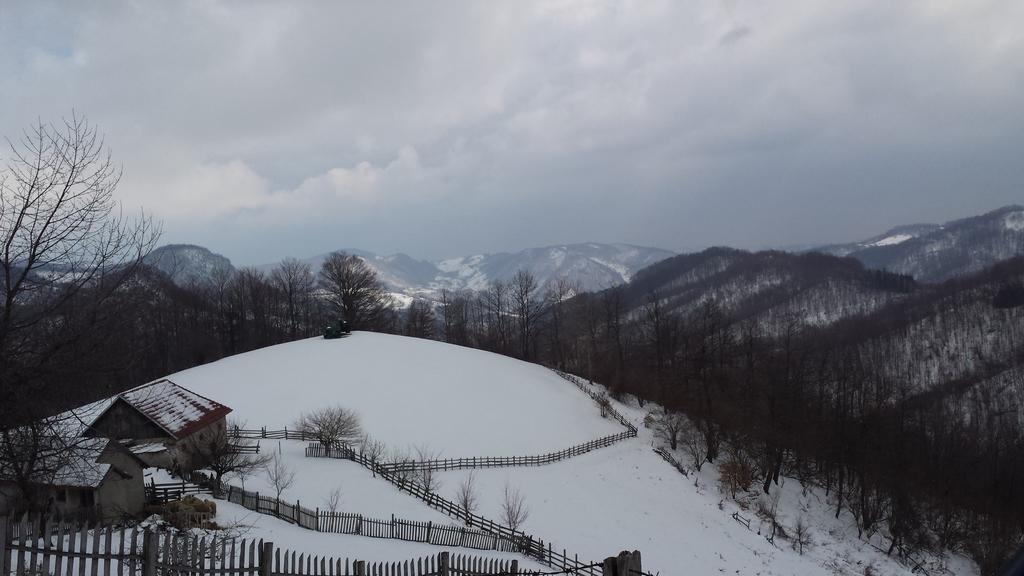Describe this image in one or two sentences. In this image I can see houses,trees and fencing. We can see snow and mountains. The sky is cloudy. 